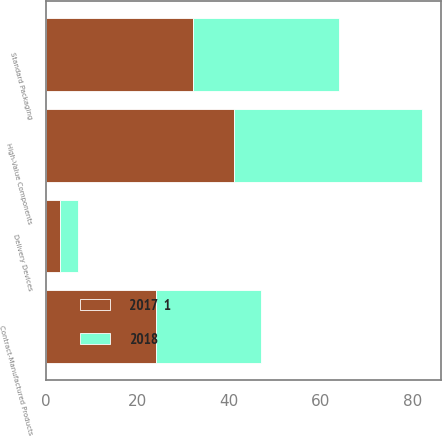Convert chart to OTSL. <chart><loc_0><loc_0><loc_500><loc_500><stacked_bar_chart><ecel><fcel>High-Value Components<fcel>Standard Packaging<fcel>Delivery Devices<fcel>Contract-Manufactured Products<nl><fcel>2017  1<fcel>41<fcel>32<fcel>3<fcel>24<nl><fcel>2018<fcel>41<fcel>32<fcel>4<fcel>23<nl></chart> 